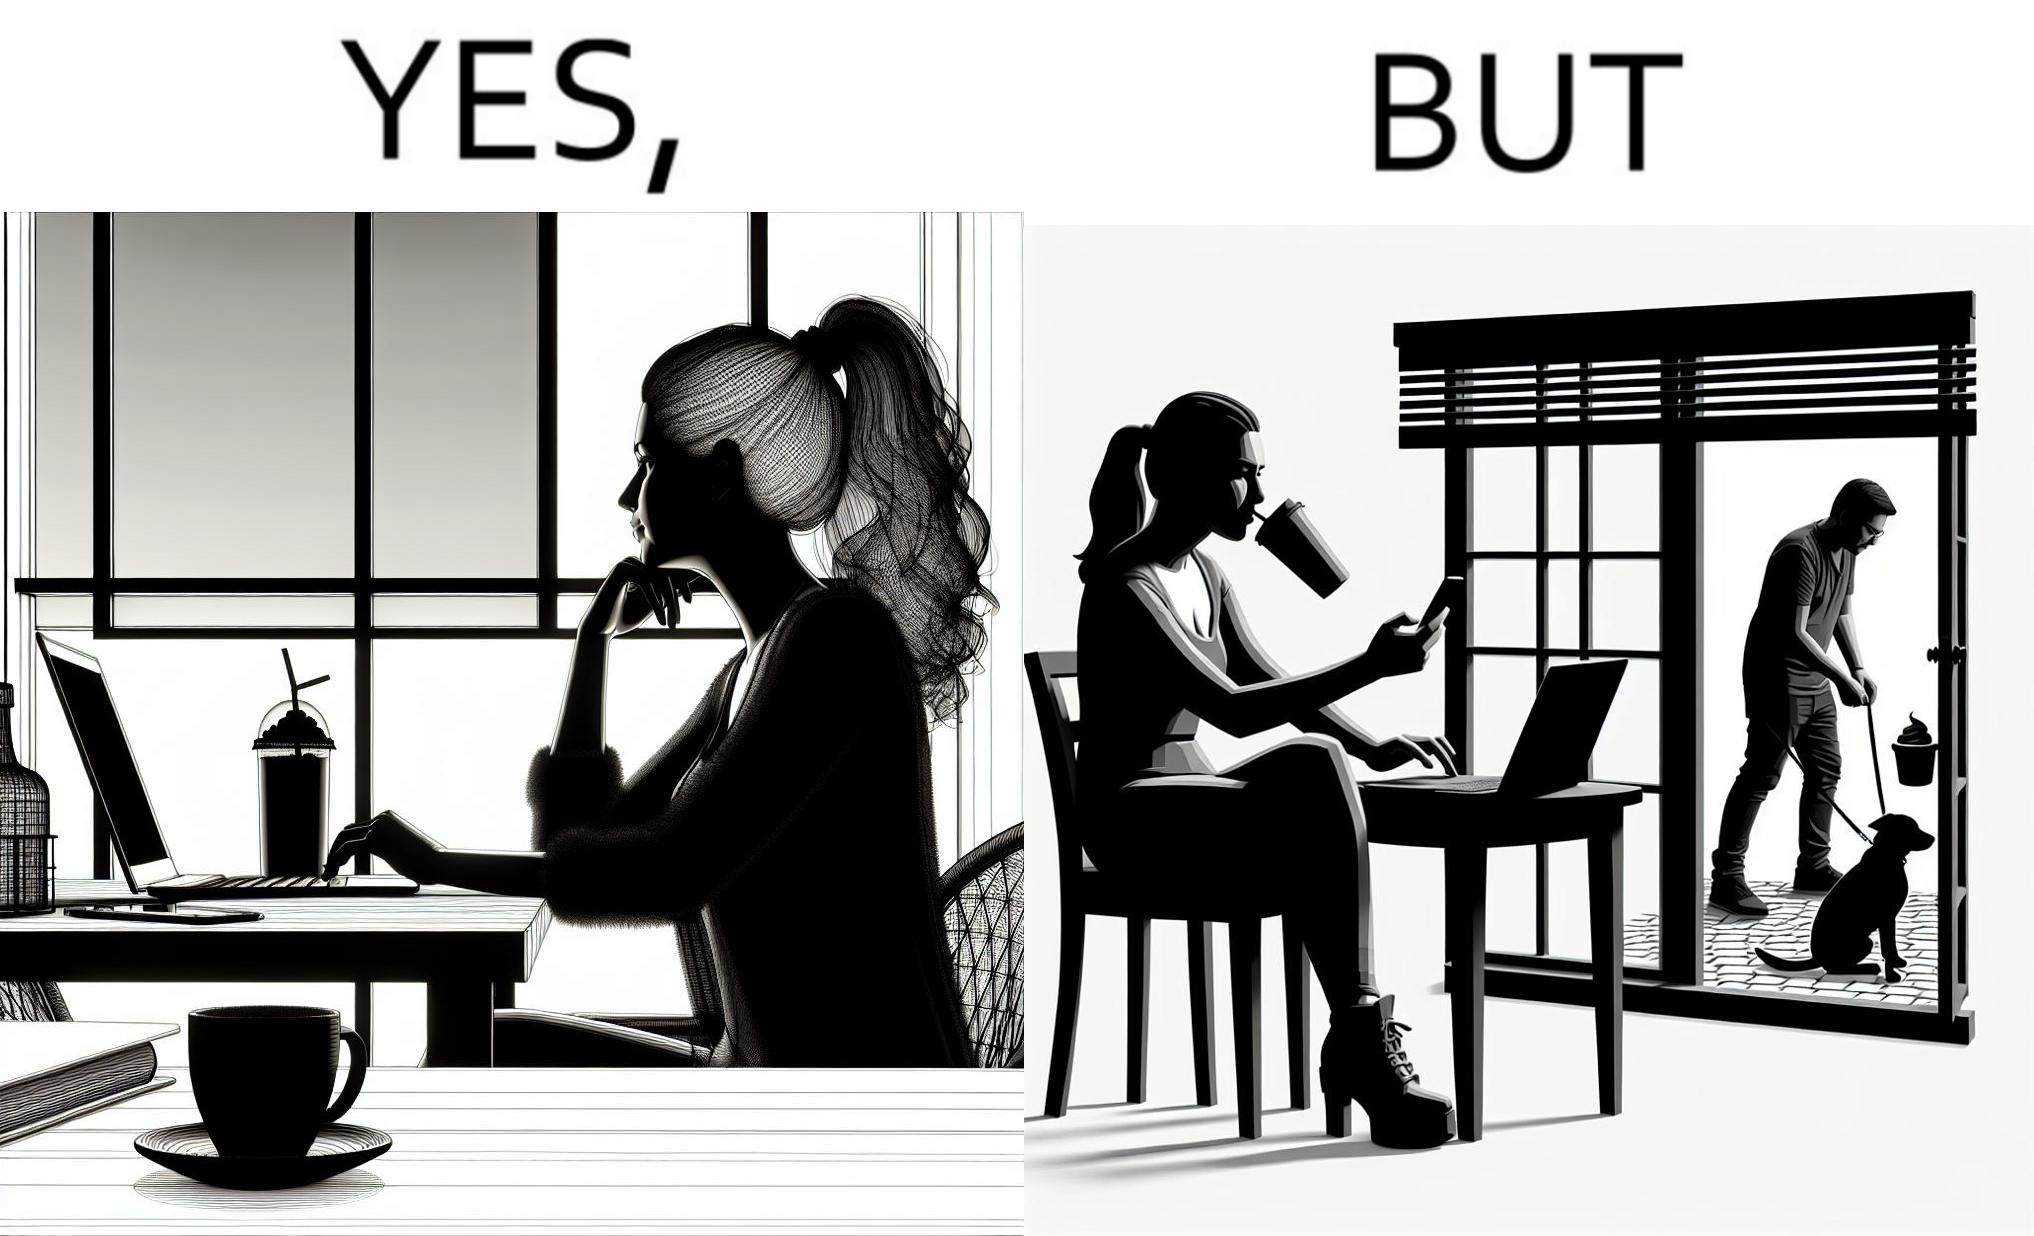Describe the contrast between the left and right parts of this image. In the left part of the image: a woman looking through the window from a cafe while enjoying her drink with working on her laptop In the right part of the image: a woman enjoying her drink and working at laptop while looking outside through the window at a person who is out for getting his dog pooped outside 